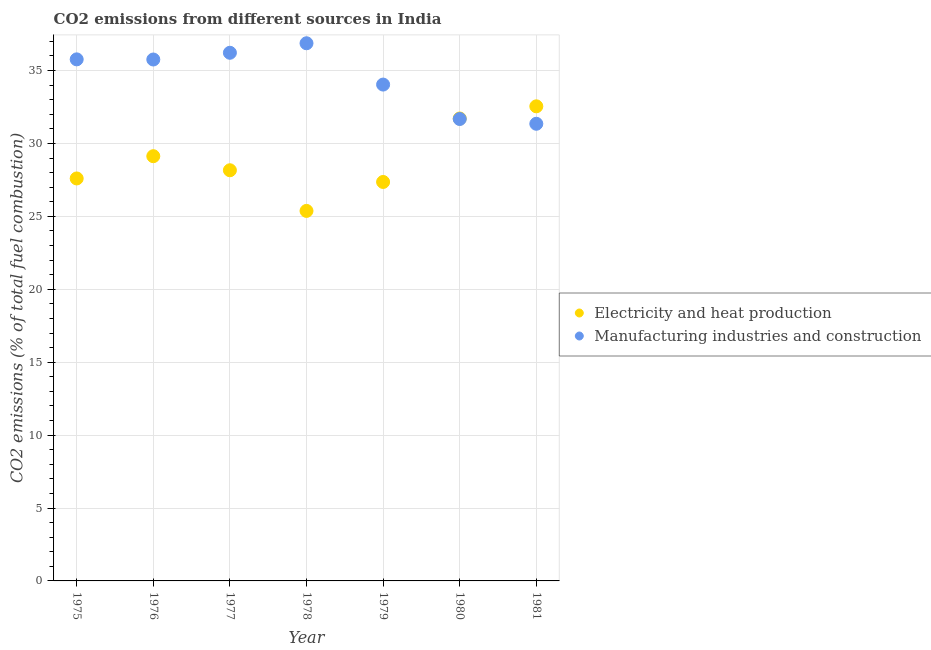Is the number of dotlines equal to the number of legend labels?
Provide a short and direct response. Yes. What is the co2 emissions due to electricity and heat production in 1978?
Provide a short and direct response. 25.37. Across all years, what is the maximum co2 emissions due to manufacturing industries?
Make the answer very short. 36.87. Across all years, what is the minimum co2 emissions due to electricity and heat production?
Offer a very short reply. 25.37. What is the total co2 emissions due to manufacturing industries in the graph?
Ensure brevity in your answer.  241.66. What is the difference between the co2 emissions due to manufacturing industries in 1979 and that in 1980?
Your response must be concise. 2.36. What is the difference between the co2 emissions due to manufacturing industries in 1979 and the co2 emissions due to electricity and heat production in 1977?
Ensure brevity in your answer.  5.88. What is the average co2 emissions due to electricity and heat production per year?
Give a very brief answer. 28.84. In the year 1977, what is the difference between the co2 emissions due to electricity and heat production and co2 emissions due to manufacturing industries?
Ensure brevity in your answer.  -8.06. In how many years, is the co2 emissions due to electricity and heat production greater than 11 %?
Keep it short and to the point. 7. What is the ratio of the co2 emissions due to manufacturing industries in 1980 to that in 1981?
Your response must be concise. 1.01. Is the difference between the co2 emissions due to electricity and heat production in 1976 and 1979 greater than the difference between the co2 emissions due to manufacturing industries in 1976 and 1979?
Offer a very short reply. Yes. What is the difference between the highest and the second highest co2 emissions due to manufacturing industries?
Give a very brief answer. 0.65. What is the difference between the highest and the lowest co2 emissions due to electricity and heat production?
Keep it short and to the point. 7.17. In how many years, is the co2 emissions due to manufacturing industries greater than the average co2 emissions due to manufacturing industries taken over all years?
Ensure brevity in your answer.  4. Does the co2 emissions due to manufacturing industries monotonically increase over the years?
Provide a succinct answer. No. Is the co2 emissions due to electricity and heat production strictly greater than the co2 emissions due to manufacturing industries over the years?
Offer a very short reply. No. How many dotlines are there?
Your response must be concise. 2. How many years are there in the graph?
Your answer should be very brief. 7. Are the values on the major ticks of Y-axis written in scientific E-notation?
Provide a short and direct response. No. Does the graph contain any zero values?
Give a very brief answer. No. How many legend labels are there?
Provide a short and direct response. 2. How are the legend labels stacked?
Your answer should be compact. Vertical. What is the title of the graph?
Offer a terse response. CO2 emissions from different sources in India. What is the label or title of the X-axis?
Keep it short and to the point. Year. What is the label or title of the Y-axis?
Offer a terse response. CO2 emissions (% of total fuel combustion). What is the CO2 emissions (% of total fuel combustion) in Electricity and heat production in 1975?
Give a very brief answer. 27.6. What is the CO2 emissions (% of total fuel combustion) in Manufacturing industries and construction in 1975?
Your answer should be very brief. 35.76. What is the CO2 emissions (% of total fuel combustion) of Electricity and heat production in 1976?
Provide a succinct answer. 29.12. What is the CO2 emissions (% of total fuel combustion) of Manufacturing industries and construction in 1976?
Ensure brevity in your answer.  35.75. What is the CO2 emissions (% of total fuel combustion) in Electricity and heat production in 1977?
Your answer should be very brief. 28.16. What is the CO2 emissions (% of total fuel combustion) of Manufacturing industries and construction in 1977?
Give a very brief answer. 36.22. What is the CO2 emissions (% of total fuel combustion) in Electricity and heat production in 1978?
Your answer should be very brief. 25.37. What is the CO2 emissions (% of total fuel combustion) in Manufacturing industries and construction in 1978?
Make the answer very short. 36.87. What is the CO2 emissions (% of total fuel combustion) in Electricity and heat production in 1979?
Offer a very short reply. 27.36. What is the CO2 emissions (% of total fuel combustion) of Manufacturing industries and construction in 1979?
Make the answer very short. 34.04. What is the CO2 emissions (% of total fuel combustion) in Electricity and heat production in 1980?
Offer a very short reply. 31.71. What is the CO2 emissions (% of total fuel combustion) of Manufacturing industries and construction in 1980?
Keep it short and to the point. 31.67. What is the CO2 emissions (% of total fuel combustion) in Electricity and heat production in 1981?
Your response must be concise. 32.54. What is the CO2 emissions (% of total fuel combustion) of Manufacturing industries and construction in 1981?
Your answer should be very brief. 31.35. Across all years, what is the maximum CO2 emissions (% of total fuel combustion) of Electricity and heat production?
Your answer should be very brief. 32.54. Across all years, what is the maximum CO2 emissions (% of total fuel combustion) in Manufacturing industries and construction?
Offer a terse response. 36.87. Across all years, what is the minimum CO2 emissions (% of total fuel combustion) of Electricity and heat production?
Provide a succinct answer. 25.37. Across all years, what is the minimum CO2 emissions (% of total fuel combustion) in Manufacturing industries and construction?
Your response must be concise. 31.35. What is the total CO2 emissions (% of total fuel combustion) of Electricity and heat production in the graph?
Your response must be concise. 201.87. What is the total CO2 emissions (% of total fuel combustion) in Manufacturing industries and construction in the graph?
Offer a terse response. 241.66. What is the difference between the CO2 emissions (% of total fuel combustion) in Electricity and heat production in 1975 and that in 1976?
Make the answer very short. -1.53. What is the difference between the CO2 emissions (% of total fuel combustion) of Manufacturing industries and construction in 1975 and that in 1976?
Ensure brevity in your answer.  0.01. What is the difference between the CO2 emissions (% of total fuel combustion) in Electricity and heat production in 1975 and that in 1977?
Keep it short and to the point. -0.56. What is the difference between the CO2 emissions (% of total fuel combustion) of Manufacturing industries and construction in 1975 and that in 1977?
Give a very brief answer. -0.45. What is the difference between the CO2 emissions (% of total fuel combustion) in Electricity and heat production in 1975 and that in 1978?
Provide a succinct answer. 2.23. What is the difference between the CO2 emissions (% of total fuel combustion) in Manufacturing industries and construction in 1975 and that in 1978?
Your answer should be compact. -1.1. What is the difference between the CO2 emissions (% of total fuel combustion) of Electricity and heat production in 1975 and that in 1979?
Your answer should be very brief. 0.24. What is the difference between the CO2 emissions (% of total fuel combustion) of Manufacturing industries and construction in 1975 and that in 1979?
Ensure brevity in your answer.  1.73. What is the difference between the CO2 emissions (% of total fuel combustion) in Electricity and heat production in 1975 and that in 1980?
Offer a very short reply. -4.11. What is the difference between the CO2 emissions (% of total fuel combustion) of Manufacturing industries and construction in 1975 and that in 1980?
Ensure brevity in your answer.  4.09. What is the difference between the CO2 emissions (% of total fuel combustion) in Electricity and heat production in 1975 and that in 1981?
Provide a succinct answer. -4.95. What is the difference between the CO2 emissions (% of total fuel combustion) of Manufacturing industries and construction in 1975 and that in 1981?
Your response must be concise. 4.42. What is the difference between the CO2 emissions (% of total fuel combustion) of Electricity and heat production in 1976 and that in 1977?
Your answer should be compact. 0.96. What is the difference between the CO2 emissions (% of total fuel combustion) in Manufacturing industries and construction in 1976 and that in 1977?
Make the answer very short. -0.46. What is the difference between the CO2 emissions (% of total fuel combustion) in Electricity and heat production in 1976 and that in 1978?
Make the answer very short. 3.75. What is the difference between the CO2 emissions (% of total fuel combustion) in Manufacturing industries and construction in 1976 and that in 1978?
Keep it short and to the point. -1.11. What is the difference between the CO2 emissions (% of total fuel combustion) in Electricity and heat production in 1976 and that in 1979?
Make the answer very short. 1.77. What is the difference between the CO2 emissions (% of total fuel combustion) of Manufacturing industries and construction in 1976 and that in 1979?
Your answer should be very brief. 1.72. What is the difference between the CO2 emissions (% of total fuel combustion) in Electricity and heat production in 1976 and that in 1980?
Provide a short and direct response. -2.59. What is the difference between the CO2 emissions (% of total fuel combustion) of Manufacturing industries and construction in 1976 and that in 1980?
Ensure brevity in your answer.  4.08. What is the difference between the CO2 emissions (% of total fuel combustion) in Electricity and heat production in 1976 and that in 1981?
Give a very brief answer. -3.42. What is the difference between the CO2 emissions (% of total fuel combustion) of Manufacturing industries and construction in 1976 and that in 1981?
Your answer should be compact. 4.41. What is the difference between the CO2 emissions (% of total fuel combustion) in Electricity and heat production in 1977 and that in 1978?
Make the answer very short. 2.79. What is the difference between the CO2 emissions (% of total fuel combustion) of Manufacturing industries and construction in 1977 and that in 1978?
Provide a succinct answer. -0.65. What is the difference between the CO2 emissions (% of total fuel combustion) of Electricity and heat production in 1977 and that in 1979?
Offer a very short reply. 0.8. What is the difference between the CO2 emissions (% of total fuel combustion) in Manufacturing industries and construction in 1977 and that in 1979?
Provide a short and direct response. 2.18. What is the difference between the CO2 emissions (% of total fuel combustion) in Electricity and heat production in 1977 and that in 1980?
Make the answer very short. -3.55. What is the difference between the CO2 emissions (% of total fuel combustion) in Manufacturing industries and construction in 1977 and that in 1980?
Offer a very short reply. 4.54. What is the difference between the CO2 emissions (% of total fuel combustion) in Electricity and heat production in 1977 and that in 1981?
Ensure brevity in your answer.  -4.38. What is the difference between the CO2 emissions (% of total fuel combustion) in Manufacturing industries and construction in 1977 and that in 1981?
Ensure brevity in your answer.  4.87. What is the difference between the CO2 emissions (% of total fuel combustion) in Electricity and heat production in 1978 and that in 1979?
Offer a very short reply. -1.99. What is the difference between the CO2 emissions (% of total fuel combustion) of Manufacturing industries and construction in 1978 and that in 1979?
Make the answer very short. 2.83. What is the difference between the CO2 emissions (% of total fuel combustion) in Electricity and heat production in 1978 and that in 1980?
Ensure brevity in your answer.  -6.34. What is the difference between the CO2 emissions (% of total fuel combustion) of Manufacturing industries and construction in 1978 and that in 1980?
Your answer should be compact. 5.19. What is the difference between the CO2 emissions (% of total fuel combustion) of Electricity and heat production in 1978 and that in 1981?
Make the answer very short. -7.17. What is the difference between the CO2 emissions (% of total fuel combustion) of Manufacturing industries and construction in 1978 and that in 1981?
Provide a succinct answer. 5.52. What is the difference between the CO2 emissions (% of total fuel combustion) in Electricity and heat production in 1979 and that in 1980?
Your answer should be very brief. -4.35. What is the difference between the CO2 emissions (% of total fuel combustion) in Manufacturing industries and construction in 1979 and that in 1980?
Make the answer very short. 2.36. What is the difference between the CO2 emissions (% of total fuel combustion) of Electricity and heat production in 1979 and that in 1981?
Your answer should be compact. -5.19. What is the difference between the CO2 emissions (% of total fuel combustion) in Manufacturing industries and construction in 1979 and that in 1981?
Your answer should be compact. 2.69. What is the difference between the CO2 emissions (% of total fuel combustion) of Electricity and heat production in 1980 and that in 1981?
Keep it short and to the point. -0.83. What is the difference between the CO2 emissions (% of total fuel combustion) in Manufacturing industries and construction in 1980 and that in 1981?
Your response must be concise. 0.33. What is the difference between the CO2 emissions (% of total fuel combustion) of Electricity and heat production in 1975 and the CO2 emissions (% of total fuel combustion) of Manufacturing industries and construction in 1976?
Your answer should be compact. -8.16. What is the difference between the CO2 emissions (% of total fuel combustion) in Electricity and heat production in 1975 and the CO2 emissions (% of total fuel combustion) in Manufacturing industries and construction in 1977?
Provide a succinct answer. -8.62. What is the difference between the CO2 emissions (% of total fuel combustion) of Electricity and heat production in 1975 and the CO2 emissions (% of total fuel combustion) of Manufacturing industries and construction in 1978?
Offer a terse response. -9.27. What is the difference between the CO2 emissions (% of total fuel combustion) in Electricity and heat production in 1975 and the CO2 emissions (% of total fuel combustion) in Manufacturing industries and construction in 1979?
Provide a short and direct response. -6.44. What is the difference between the CO2 emissions (% of total fuel combustion) of Electricity and heat production in 1975 and the CO2 emissions (% of total fuel combustion) of Manufacturing industries and construction in 1980?
Offer a terse response. -4.08. What is the difference between the CO2 emissions (% of total fuel combustion) of Electricity and heat production in 1975 and the CO2 emissions (% of total fuel combustion) of Manufacturing industries and construction in 1981?
Your response must be concise. -3.75. What is the difference between the CO2 emissions (% of total fuel combustion) of Electricity and heat production in 1976 and the CO2 emissions (% of total fuel combustion) of Manufacturing industries and construction in 1977?
Your answer should be compact. -7.09. What is the difference between the CO2 emissions (% of total fuel combustion) in Electricity and heat production in 1976 and the CO2 emissions (% of total fuel combustion) in Manufacturing industries and construction in 1978?
Offer a very short reply. -7.74. What is the difference between the CO2 emissions (% of total fuel combustion) of Electricity and heat production in 1976 and the CO2 emissions (% of total fuel combustion) of Manufacturing industries and construction in 1979?
Your answer should be compact. -4.91. What is the difference between the CO2 emissions (% of total fuel combustion) in Electricity and heat production in 1976 and the CO2 emissions (% of total fuel combustion) in Manufacturing industries and construction in 1980?
Provide a succinct answer. -2.55. What is the difference between the CO2 emissions (% of total fuel combustion) in Electricity and heat production in 1976 and the CO2 emissions (% of total fuel combustion) in Manufacturing industries and construction in 1981?
Provide a succinct answer. -2.22. What is the difference between the CO2 emissions (% of total fuel combustion) of Electricity and heat production in 1977 and the CO2 emissions (% of total fuel combustion) of Manufacturing industries and construction in 1978?
Provide a short and direct response. -8.71. What is the difference between the CO2 emissions (% of total fuel combustion) of Electricity and heat production in 1977 and the CO2 emissions (% of total fuel combustion) of Manufacturing industries and construction in 1979?
Give a very brief answer. -5.88. What is the difference between the CO2 emissions (% of total fuel combustion) in Electricity and heat production in 1977 and the CO2 emissions (% of total fuel combustion) in Manufacturing industries and construction in 1980?
Your response must be concise. -3.51. What is the difference between the CO2 emissions (% of total fuel combustion) in Electricity and heat production in 1977 and the CO2 emissions (% of total fuel combustion) in Manufacturing industries and construction in 1981?
Your response must be concise. -3.19. What is the difference between the CO2 emissions (% of total fuel combustion) in Electricity and heat production in 1978 and the CO2 emissions (% of total fuel combustion) in Manufacturing industries and construction in 1979?
Your response must be concise. -8.66. What is the difference between the CO2 emissions (% of total fuel combustion) in Electricity and heat production in 1978 and the CO2 emissions (% of total fuel combustion) in Manufacturing industries and construction in 1980?
Offer a very short reply. -6.3. What is the difference between the CO2 emissions (% of total fuel combustion) in Electricity and heat production in 1978 and the CO2 emissions (% of total fuel combustion) in Manufacturing industries and construction in 1981?
Offer a very short reply. -5.98. What is the difference between the CO2 emissions (% of total fuel combustion) in Electricity and heat production in 1979 and the CO2 emissions (% of total fuel combustion) in Manufacturing industries and construction in 1980?
Your answer should be compact. -4.32. What is the difference between the CO2 emissions (% of total fuel combustion) in Electricity and heat production in 1979 and the CO2 emissions (% of total fuel combustion) in Manufacturing industries and construction in 1981?
Your answer should be compact. -3.99. What is the difference between the CO2 emissions (% of total fuel combustion) in Electricity and heat production in 1980 and the CO2 emissions (% of total fuel combustion) in Manufacturing industries and construction in 1981?
Ensure brevity in your answer.  0.36. What is the average CO2 emissions (% of total fuel combustion) in Electricity and heat production per year?
Give a very brief answer. 28.84. What is the average CO2 emissions (% of total fuel combustion) in Manufacturing industries and construction per year?
Keep it short and to the point. 34.52. In the year 1975, what is the difference between the CO2 emissions (% of total fuel combustion) in Electricity and heat production and CO2 emissions (% of total fuel combustion) in Manufacturing industries and construction?
Offer a very short reply. -8.17. In the year 1976, what is the difference between the CO2 emissions (% of total fuel combustion) in Electricity and heat production and CO2 emissions (% of total fuel combustion) in Manufacturing industries and construction?
Keep it short and to the point. -6.63. In the year 1977, what is the difference between the CO2 emissions (% of total fuel combustion) of Electricity and heat production and CO2 emissions (% of total fuel combustion) of Manufacturing industries and construction?
Keep it short and to the point. -8.06. In the year 1978, what is the difference between the CO2 emissions (% of total fuel combustion) in Electricity and heat production and CO2 emissions (% of total fuel combustion) in Manufacturing industries and construction?
Your response must be concise. -11.5. In the year 1979, what is the difference between the CO2 emissions (% of total fuel combustion) of Electricity and heat production and CO2 emissions (% of total fuel combustion) of Manufacturing industries and construction?
Your answer should be very brief. -6.68. In the year 1980, what is the difference between the CO2 emissions (% of total fuel combustion) in Electricity and heat production and CO2 emissions (% of total fuel combustion) in Manufacturing industries and construction?
Give a very brief answer. 0.04. In the year 1981, what is the difference between the CO2 emissions (% of total fuel combustion) of Electricity and heat production and CO2 emissions (% of total fuel combustion) of Manufacturing industries and construction?
Provide a short and direct response. 1.2. What is the ratio of the CO2 emissions (% of total fuel combustion) of Electricity and heat production in 1975 to that in 1976?
Ensure brevity in your answer.  0.95. What is the ratio of the CO2 emissions (% of total fuel combustion) in Manufacturing industries and construction in 1975 to that in 1976?
Offer a very short reply. 1. What is the ratio of the CO2 emissions (% of total fuel combustion) of Electricity and heat production in 1975 to that in 1977?
Provide a succinct answer. 0.98. What is the ratio of the CO2 emissions (% of total fuel combustion) in Manufacturing industries and construction in 1975 to that in 1977?
Give a very brief answer. 0.99. What is the ratio of the CO2 emissions (% of total fuel combustion) in Electricity and heat production in 1975 to that in 1978?
Offer a very short reply. 1.09. What is the ratio of the CO2 emissions (% of total fuel combustion) of Manufacturing industries and construction in 1975 to that in 1978?
Offer a terse response. 0.97. What is the ratio of the CO2 emissions (% of total fuel combustion) of Electricity and heat production in 1975 to that in 1979?
Give a very brief answer. 1.01. What is the ratio of the CO2 emissions (% of total fuel combustion) of Manufacturing industries and construction in 1975 to that in 1979?
Keep it short and to the point. 1.05. What is the ratio of the CO2 emissions (% of total fuel combustion) of Electricity and heat production in 1975 to that in 1980?
Your answer should be compact. 0.87. What is the ratio of the CO2 emissions (% of total fuel combustion) in Manufacturing industries and construction in 1975 to that in 1980?
Provide a succinct answer. 1.13. What is the ratio of the CO2 emissions (% of total fuel combustion) of Electricity and heat production in 1975 to that in 1981?
Give a very brief answer. 0.85. What is the ratio of the CO2 emissions (% of total fuel combustion) in Manufacturing industries and construction in 1975 to that in 1981?
Your answer should be compact. 1.14. What is the ratio of the CO2 emissions (% of total fuel combustion) of Electricity and heat production in 1976 to that in 1977?
Give a very brief answer. 1.03. What is the ratio of the CO2 emissions (% of total fuel combustion) of Manufacturing industries and construction in 1976 to that in 1977?
Make the answer very short. 0.99. What is the ratio of the CO2 emissions (% of total fuel combustion) of Electricity and heat production in 1976 to that in 1978?
Provide a succinct answer. 1.15. What is the ratio of the CO2 emissions (% of total fuel combustion) of Manufacturing industries and construction in 1976 to that in 1978?
Keep it short and to the point. 0.97. What is the ratio of the CO2 emissions (% of total fuel combustion) in Electricity and heat production in 1976 to that in 1979?
Make the answer very short. 1.06. What is the ratio of the CO2 emissions (% of total fuel combustion) in Manufacturing industries and construction in 1976 to that in 1979?
Your response must be concise. 1.05. What is the ratio of the CO2 emissions (% of total fuel combustion) of Electricity and heat production in 1976 to that in 1980?
Offer a terse response. 0.92. What is the ratio of the CO2 emissions (% of total fuel combustion) in Manufacturing industries and construction in 1976 to that in 1980?
Give a very brief answer. 1.13. What is the ratio of the CO2 emissions (% of total fuel combustion) in Electricity and heat production in 1976 to that in 1981?
Keep it short and to the point. 0.89. What is the ratio of the CO2 emissions (% of total fuel combustion) in Manufacturing industries and construction in 1976 to that in 1981?
Make the answer very short. 1.14. What is the ratio of the CO2 emissions (% of total fuel combustion) of Electricity and heat production in 1977 to that in 1978?
Your answer should be compact. 1.11. What is the ratio of the CO2 emissions (% of total fuel combustion) of Manufacturing industries and construction in 1977 to that in 1978?
Offer a very short reply. 0.98. What is the ratio of the CO2 emissions (% of total fuel combustion) of Electricity and heat production in 1977 to that in 1979?
Offer a very short reply. 1.03. What is the ratio of the CO2 emissions (% of total fuel combustion) of Manufacturing industries and construction in 1977 to that in 1979?
Make the answer very short. 1.06. What is the ratio of the CO2 emissions (% of total fuel combustion) of Electricity and heat production in 1977 to that in 1980?
Your answer should be compact. 0.89. What is the ratio of the CO2 emissions (% of total fuel combustion) in Manufacturing industries and construction in 1977 to that in 1980?
Your response must be concise. 1.14. What is the ratio of the CO2 emissions (% of total fuel combustion) of Electricity and heat production in 1977 to that in 1981?
Provide a succinct answer. 0.87. What is the ratio of the CO2 emissions (% of total fuel combustion) of Manufacturing industries and construction in 1977 to that in 1981?
Your answer should be compact. 1.16. What is the ratio of the CO2 emissions (% of total fuel combustion) of Electricity and heat production in 1978 to that in 1979?
Ensure brevity in your answer.  0.93. What is the ratio of the CO2 emissions (% of total fuel combustion) in Manufacturing industries and construction in 1978 to that in 1979?
Ensure brevity in your answer.  1.08. What is the ratio of the CO2 emissions (% of total fuel combustion) of Electricity and heat production in 1978 to that in 1980?
Provide a succinct answer. 0.8. What is the ratio of the CO2 emissions (% of total fuel combustion) in Manufacturing industries and construction in 1978 to that in 1980?
Your answer should be very brief. 1.16. What is the ratio of the CO2 emissions (% of total fuel combustion) in Electricity and heat production in 1978 to that in 1981?
Offer a terse response. 0.78. What is the ratio of the CO2 emissions (% of total fuel combustion) of Manufacturing industries and construction in 1978 to that in 1981?
Provide a succinct answer. 1.18. What is the ratio of the CO2 emissions (% of total fuel combustion) in Electricity and heat production in 1979 to that in 1980?
Provide a succinct answer. 0.86. What is the ratio of the CO2 emissions (% of total fuel combustion) in Manufacturing industries and construction in 1979 to that in 1980?
Provide a short and direct response. 1.07. What is the ratio of the CO2 emissions (% of total fuel combustion) of Electricity and heat production in 1979 to that in 1981?
Your response must be concise. 0.84. What is the ratio of the CO2 emissions (% of total fuel combustion) of Manufacturing industries and construction in 1979 to that in 1981?
Your response must be concise. 1.09. What is the ratio of the CO2 emissions (% of total fuel combustion) of Electricity and heat production in 1980 to that in 1981?
Make the answer very short. 0.97. What is the ratio of the CO2 emissions (% of total fuel combustion) in Manufacturing industries and construction in 1980 to that in 1981?
Give a very brief answer. 1.01. What is the difference between the highest and the second highest CO2 emissions (% of total fuel combustion) in Electricity and heat production?
Ensure brevity in your answer.  0.83. What is the difference between the highest and the second highest CO2 emissions (% of total fuel combustion) in Manufacturing industries and construction?
Your answer should be very brief. 0.65. What is the difference between the highest and the lowest CO2 emissions (% of total fuel combustion) of Electricity and heat production?
Keep it short and to the point. 7.17. What is the difference between the highest and the lowest CO2 emissions (% of total fuel combustion) in Manufacturing industries and construction?
Make the answer very short. 5.52. 